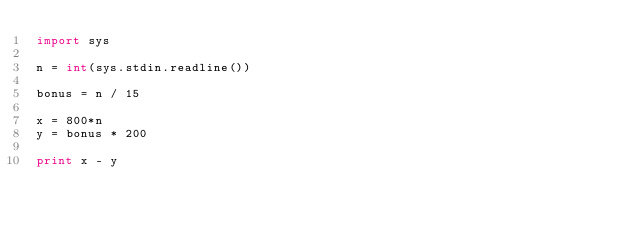<code> <loc_0><loc_0><loc_500><loc_500><_Python_>import sys

n = int(sys.stdin.readline())

bonus = n / 15

x = 800*n
y = bonus * 200

print x - y
</code> 